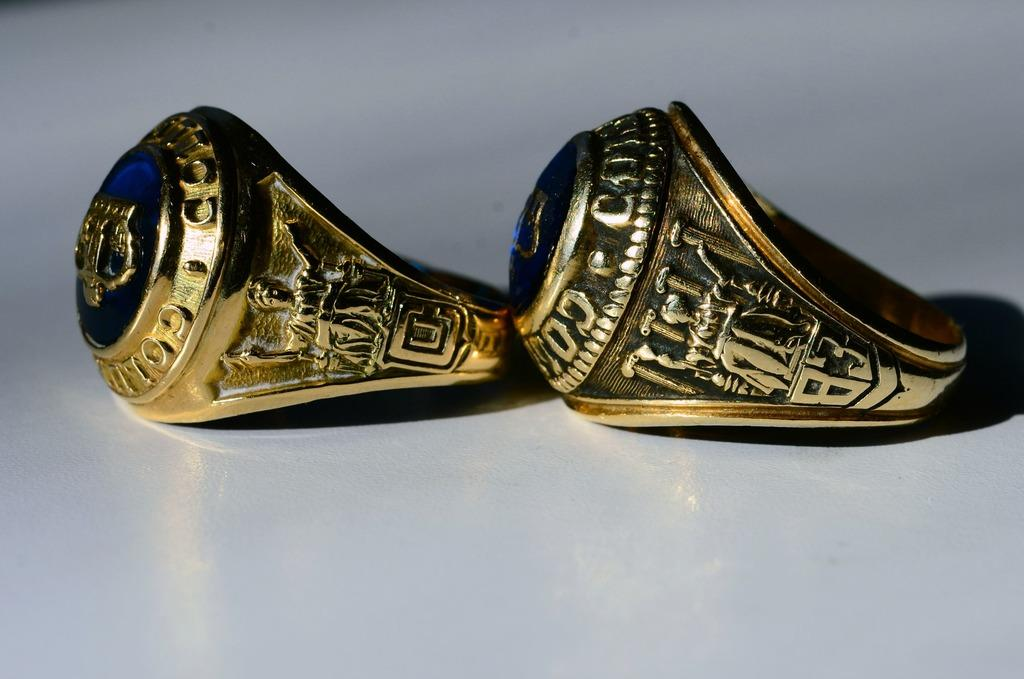How many rings are present in the image? There are two rings in the image. What can be found on the rings? There are sculptures on the rings. Are there any snakes visible on the rings in the image? No, there are no snakes present in the image. The rings have sculptures on them, but no snakes are mentioned or visible. 